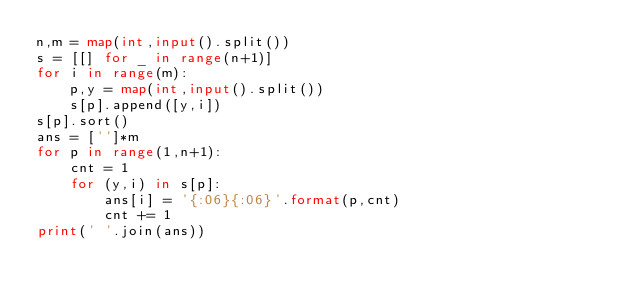Convert code to text. <code><loc_0><loc_0><loc_500><loc_500><_Python_>n,m = map(int,input().split())
s = [[] for _ in range(n+1)]
for i in range(m):
    p,y = map(int,input().split())
    s[p].append([y,i])
s[p].sort()
ans = ['']*m
for p in range(1,n+1):
    cnt = 1
    for (y,i) in s[p]:
        ans[i] = '{:06}{:06}'.format(p,cnt)
        cnt += 1
print(' '.join(ans))</code> 